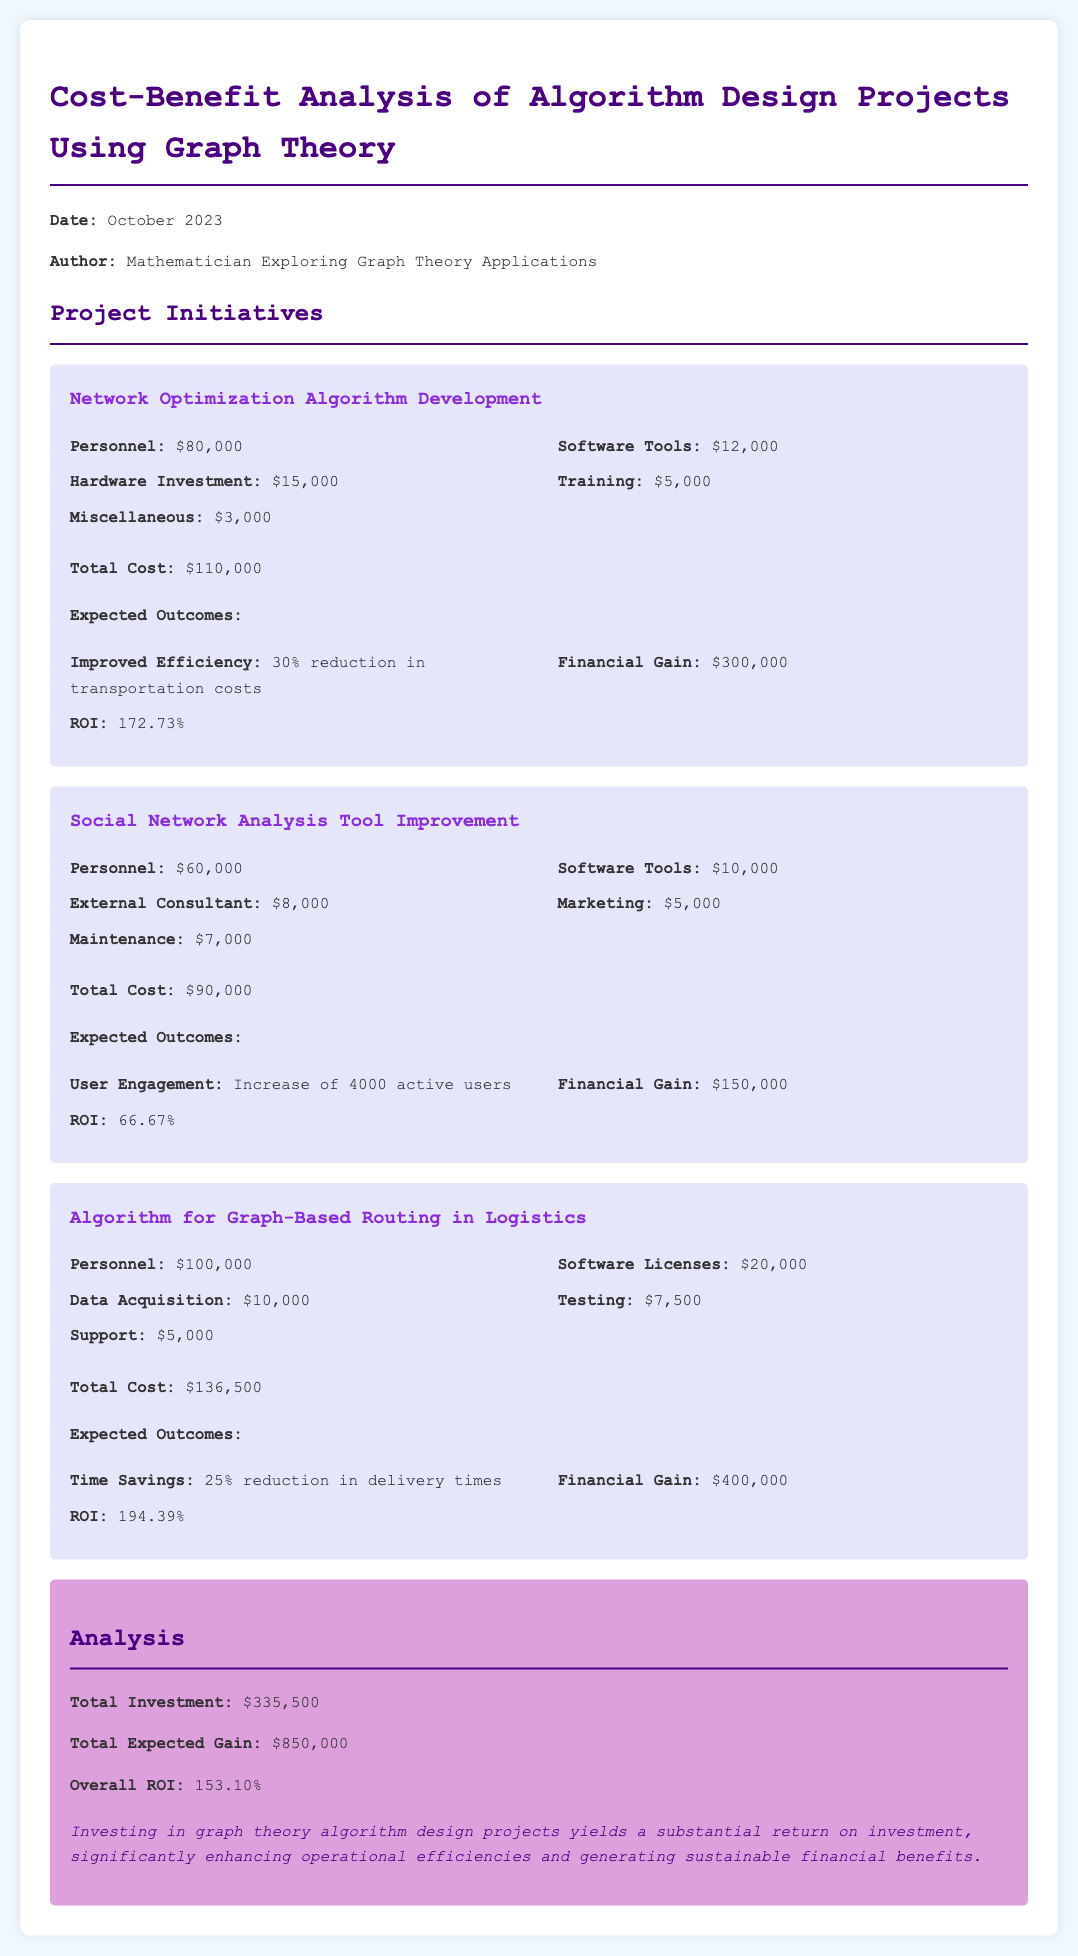what is the total cost of the Network Optimization Algorithm Development project? The total cost is stated in the document for this specific project.
Answer: $110,000 what is the expected financial gain from the Algorithm for Graph-Based Routing in Logistics? The expected financial gain is detailed in the outcomes section for this project.
Answer: $400,000 what is the ROI of the Social Network Analysis Tool Improvement project? The ROI is provided as a specific outcome measure related to this project.
Answer: 66.67% how much did the personnel cost for the Algorithm for Graph-Based Routing in Logistics project? The cost for personnel is specified in the cost breakdown of the project section.
Answer: $100,000 what is the overall ROI for all projects combined? The overall ROI is calculated based on the total investment and total expected gain across all initiatives.
Answer: 153.10% how many active users is expected to increase from the Social Network Analysis Tool Improvement? The expected increase in active users is highlighted in the outcomes section for this project.
Answer: 4000 active users what is the total expected gain from all projects combined? The total expected gain summation is mentioned in the analysis section of the document.
Answer: $850,000 what is the total investment made in all projects? The total investment figure is summarized in the analysis part of the report.
Answer: $335,500 what type of analysis is performed in this report? The report provides a specific type of financial analysis regarding project costs and benefits.
Answer: Cost-Benefit Analysis 